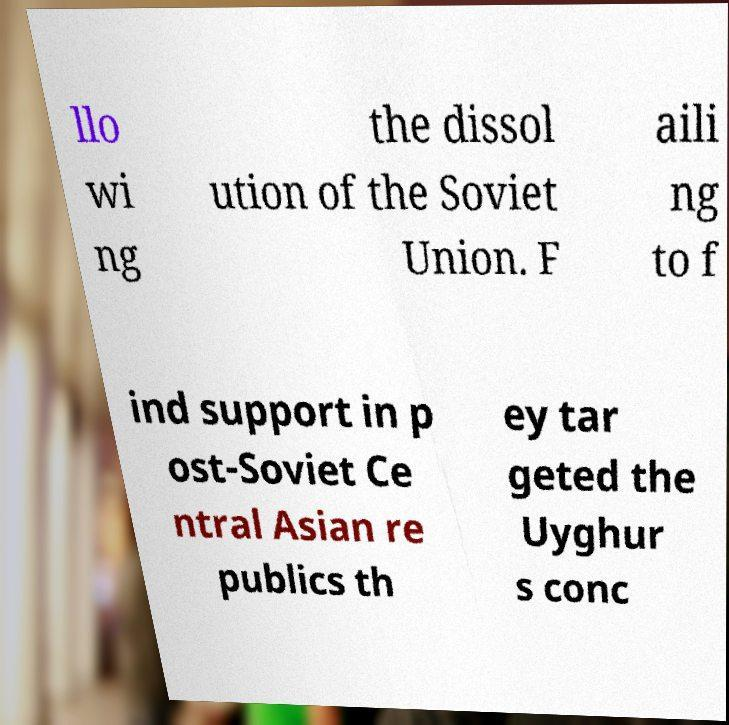Can you accurately transcribe the text from the provided image for me? llo wi ng the dissol ution of the Soviet Union. F aili ng to f ind support in p ost-Soviet Ce ntral Asian re publics th ey tar geted the Uyghur s conc 